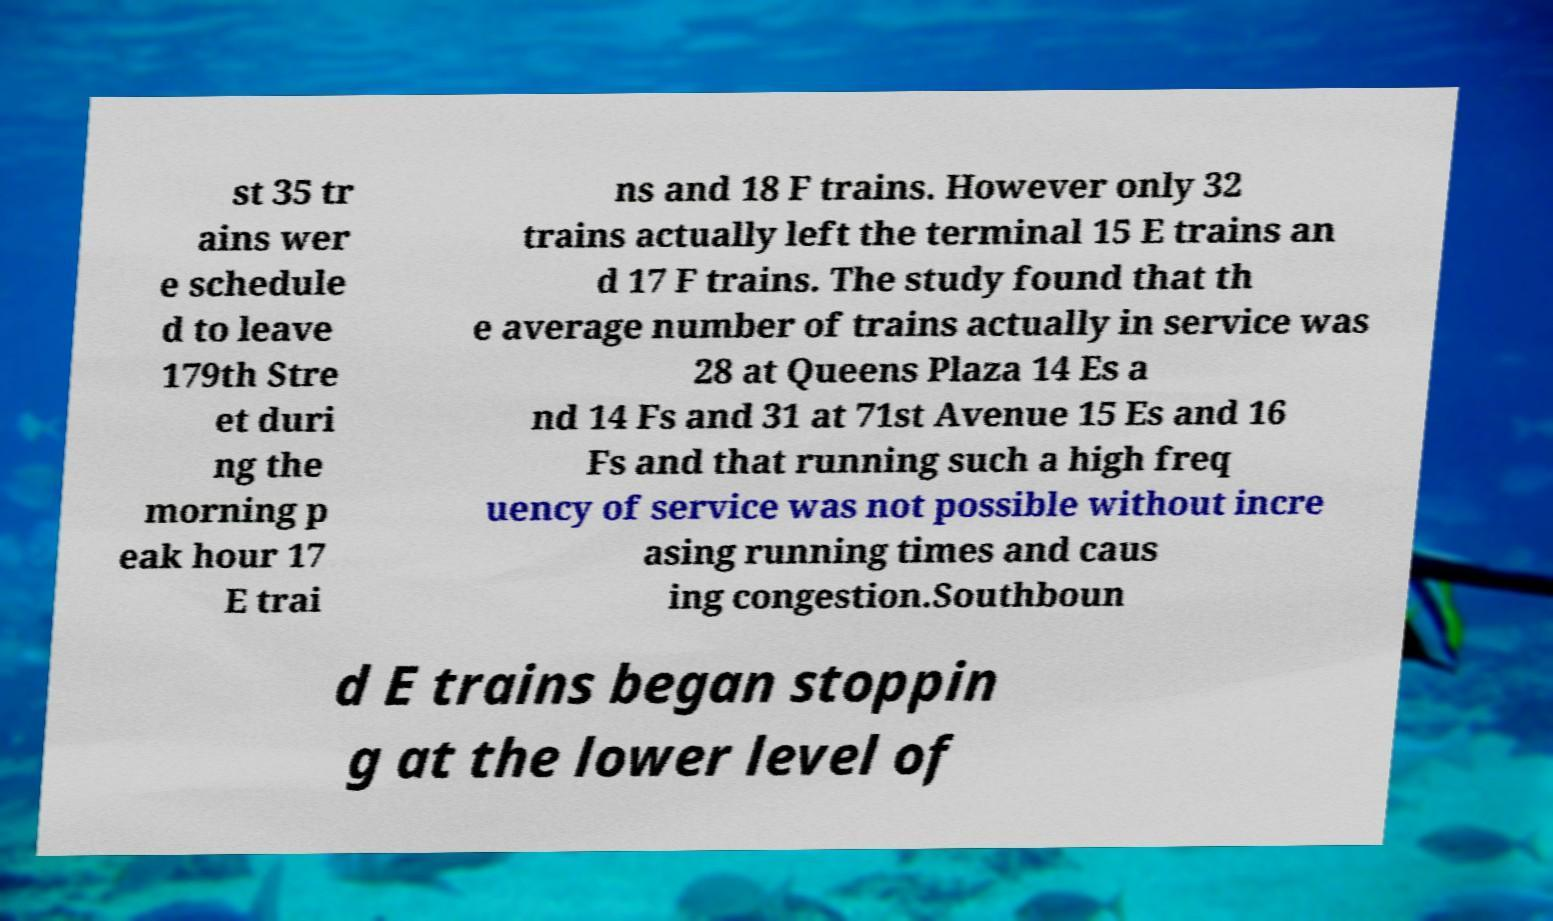There's text embedded in this image that I need extracted. Can you transcribe it verbatim? st 35 tr ains wer e schedule d to leave 179th Stre et duri ng the morning p eak hour 17 E trai ns and 18 F trains. However only 32 trains actually left the terminal 15 E trains an d 17 F trains. The study found that th e average number of trains actually in service was 28 at Queens Plaza 14 Es a nd 14 Fs and 31 at 71st Avenue 15 Es and 16 Fs and that running such a high freq uency of service was not possible without incre asing running times and caus ing congestion.Southboun d E trains began stoppin g at the lower level of 